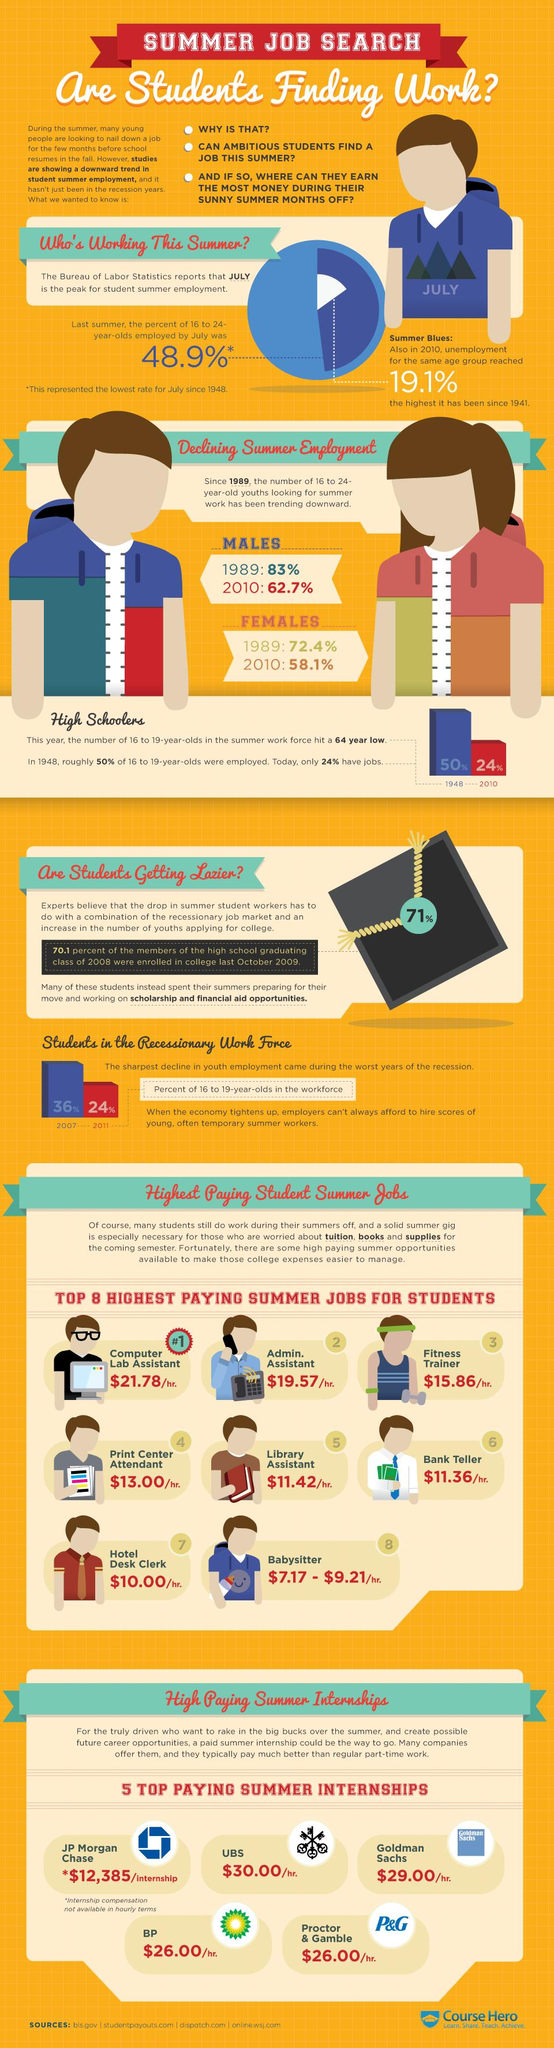Give some essential details in this illustration. In 2010, approximately 24% of 16 to 19 year old youth were employed. In 2010, it was found that 62.7% of males in the age group of 16-24 were seeking summer work. According to recent data, the position of computer lab assistant is the highest paid job for students. According to a reliable source, JP Morgan Chase is the company that offers the highest payment for summer internships of students. In 1989, it was reported that 72.4% of females in the age group of 16-24 were actively seeking summer work. 